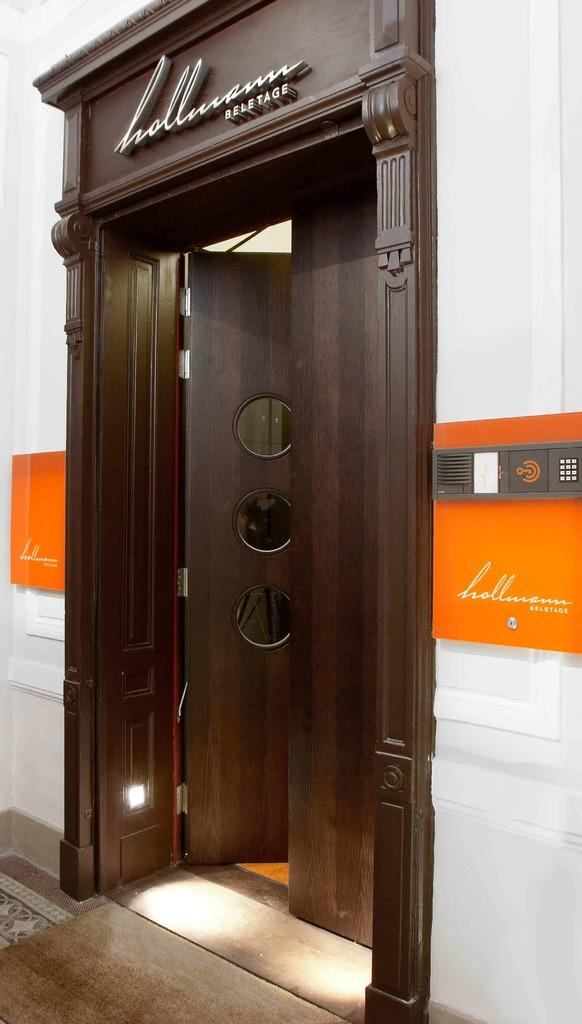What is the color of the door in the image? The door in the image is brown. What is the color of the wall in the image? The wall in the image is white. What is attached to the wall in the image? There is an orange color board on the wall. Can you see any dirt on the ship in the image? There is no ship present in the image, so it is not possible to see any dirt on it. 